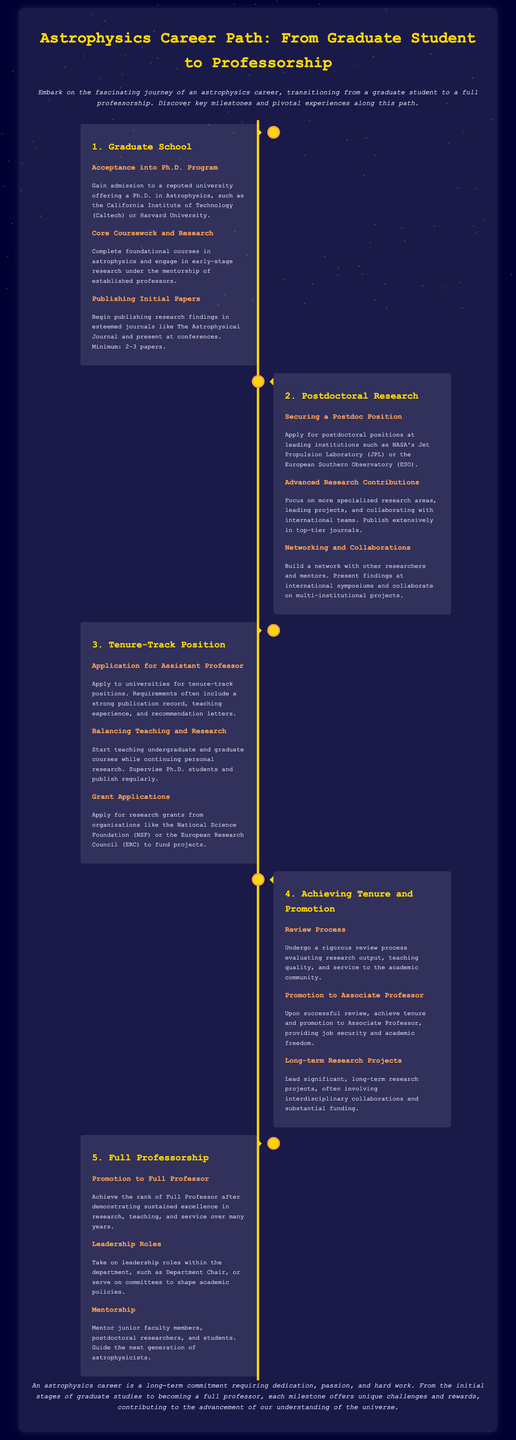What is the first milestone in the career path? The first milestone in the career path outlined in the document is Graduate School.
Answer: Graduate School How many papers should a graduate student aim to publish? The document states a minimum of 2-3 papers should be published during graduate studies.
Answer: 2-3 papers What position does one apply for after completing a postdoctoral research? After completing postdoctoral research, the next position to apply for is Assistant Professor.
Answer: Assistant Professor What is required for promotion to Associate Professor? The promotion to Associate Professor requires a successful review process evaluating research output, teaching quality, and service to the academic community.
Answer: Review Process What are two responsibilities of a Full Professor? The two responsibilities of a Full Professor include taking on leadership roles within the department and mentoring junior faculty members.
Answer: Leadership Roles, Mentorship What is the main focus during the tenure-track position? The main focus during the tenure-track position is balancing teaching and research.
Answer: Balancing Teaching and Research How many institutions are suggested for postdoctoral positions? The document mentions two institutions: NASA's Jet Propulsion Laboratory and the European Southern Observatory.
Answer: Two institutions What is the concluding statement of the infographic? The concluding statement emphasizes the long-term commitment required for an astrophysics career.
Answer: Long-term commitment 